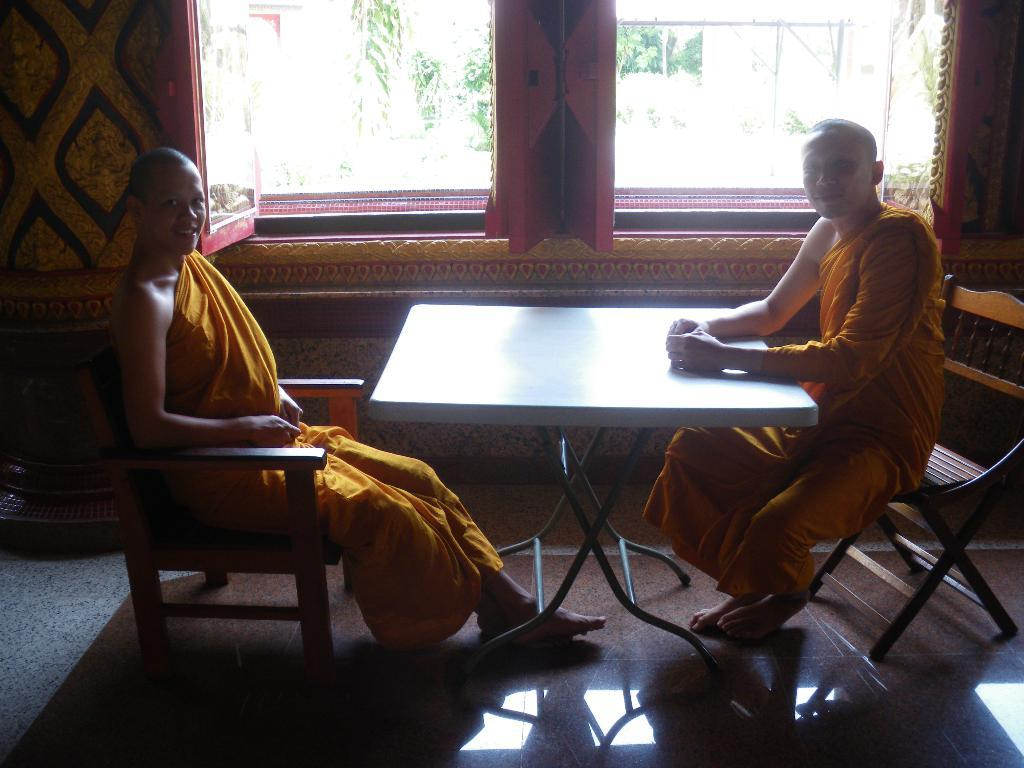How many people are in the image? There are two men in the image. What are the men doing in the image? The men are sitting on chairs. What expression do the men have in the image? The men have smiles on their faces. What is present in the image besides the men? There is a table in the image. What can be seen in the background of the image? There are trees in the background of the image. Who is the owner of the gate in the image? There is no gate present in the image. What items are on the list that the men are discussing in the image? There is no list or discussion about a list in the image. 